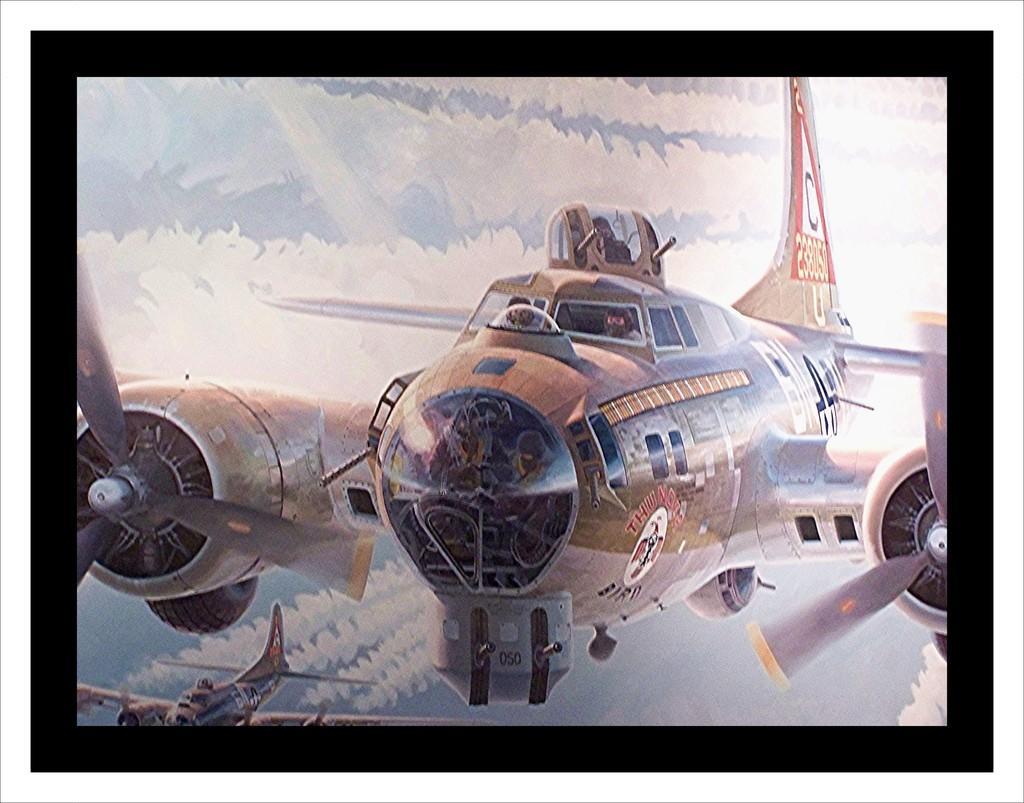Can you describe this image briefly? Planes are in the air. Inside this planet we can see people. Smoke is coming out from another plane. Background we can see the sky.  